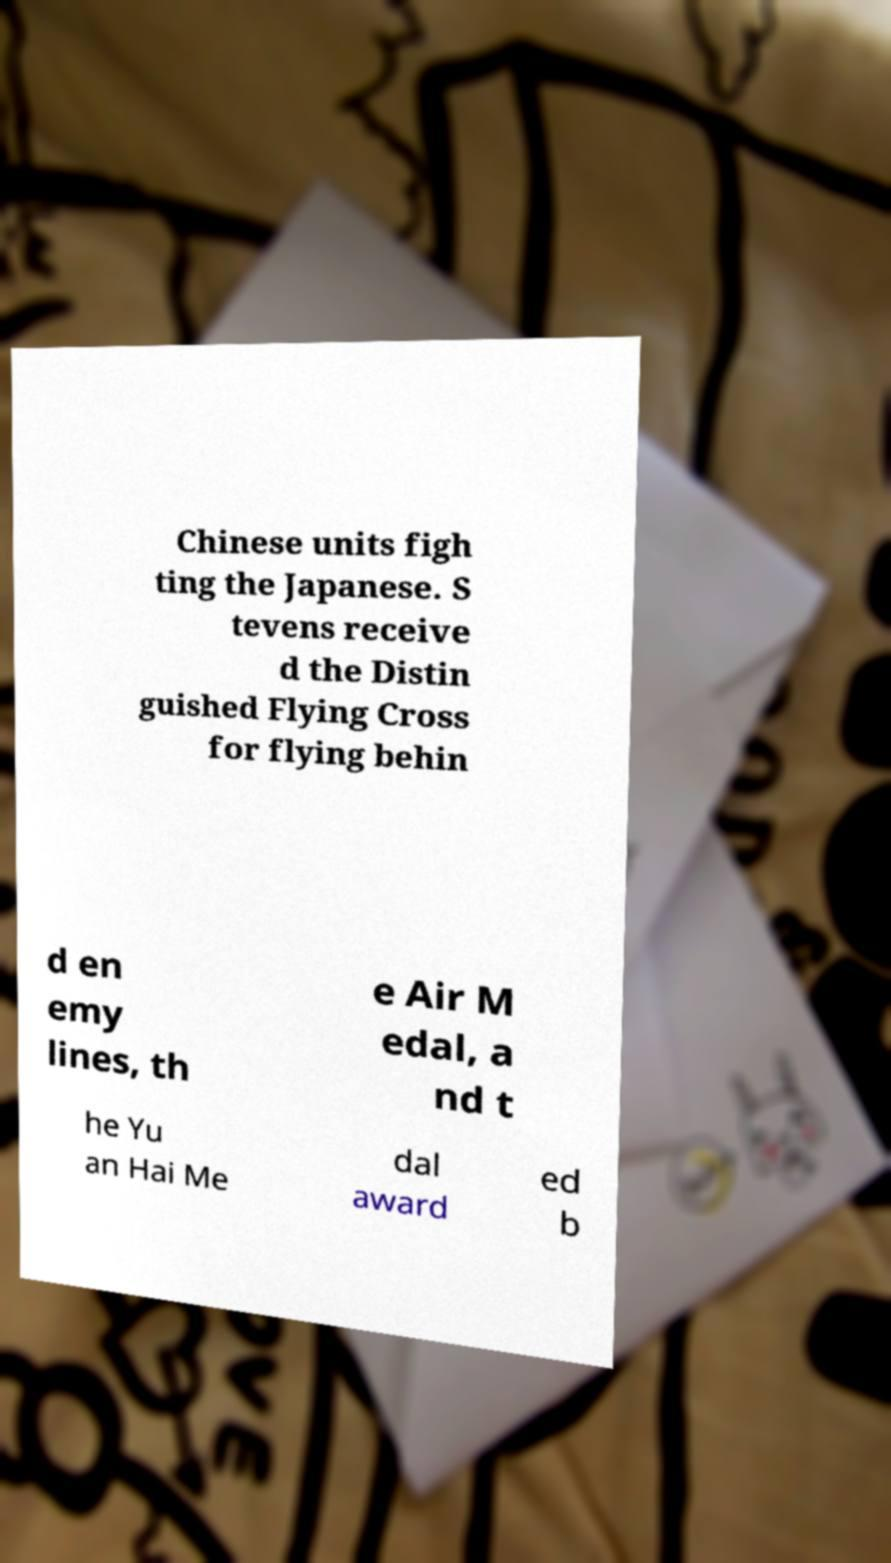Can you accurately transcribe the text from the provided image for me? Chinese units figh ting the Japanese. S tevens receive d the Distin guished Flying Cross for flying behin d en emy lines, th e Air M edal, a nd t he Yu an Hai Me dal award ed b 